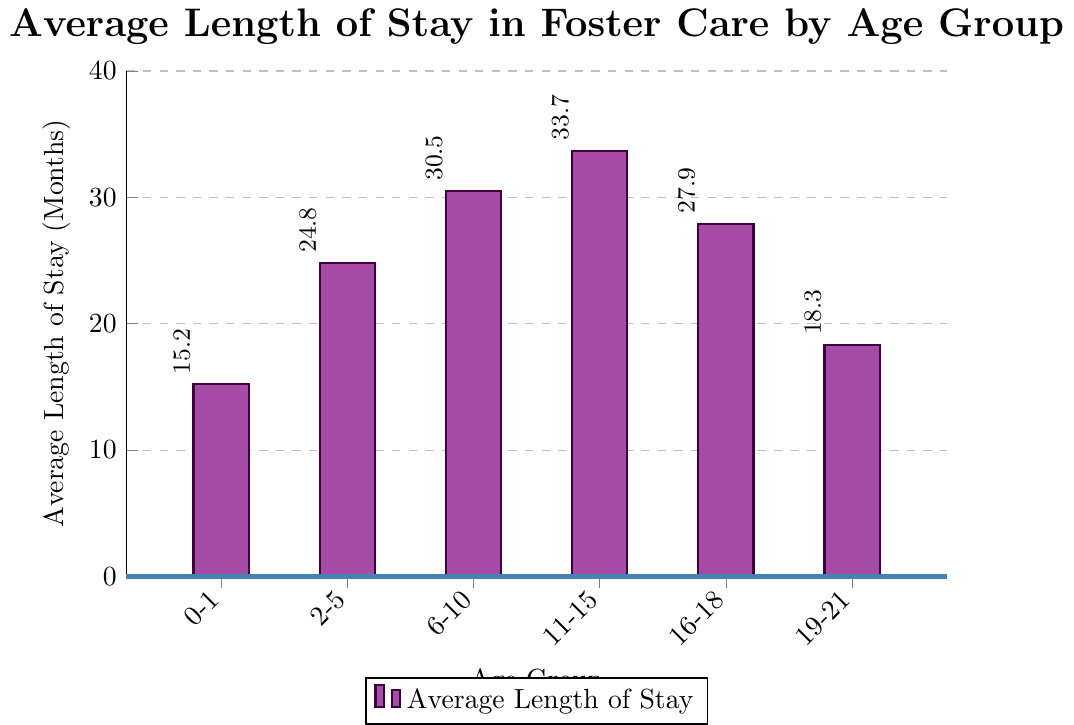Which age group has the longest average length of stay in foster care? The bar representing the age group 11-15 years reaches the highest point on the y-axis.
Answer: 11-15 years What is the difference in the average length of stay between the age group 11-15 years and 0-1 years? The average length of stay for 11-15 years is 33.7 months and for 0-1 years it is 15.2 months. The difference is 33.7 - 15.2 = 18.5 months.
Answer: 18.5 months How many age groups have an average length of stay longer than 25 months? The bars for the age groups 6-10 years, 11-15 years, and 16-18 years extend above the 25-month mark.
Answer: 3 age groups Which age group has a shorter average length of stay: 6-10 years or 16-18 years? The average length of stay for 6-10 years is 30.5 months, and for 16-18 years is 27.9 months. Since 27.9 is less than 30.5, 16-18 years has a shorter average length of stay.
Answer: 16-18 years What is the combined average length of stay for the age groups 2-5 years and 19-21 years? The average length of stay for 2-5 years is 24.8 months and for 19-21 years it is 18.3 months. The combined value is 24.8 + 18.3 = 43.1 months.
Answer: 43.1 months By how much does the average length of stay for the age group 6-10 years exceed the stay for 2-5 years? The average length of stay for 6-10 years is 30.5 months, and for 2-5 years it is 24.8 months. The difference is 30.5 - 24.8 = 5.7 months.
Answer: 5.7 months Identify any age groups with an average length of stay shorter than 20 months. The average length of stay for the age groups 0-1 years (15.2 months) and 19-21 years (18.3 months) are both less than 20 months.
Answer: 0-1 years, 19-21 years What is the average of the average lengths of stay across all age groups? Sum the average lengths of stay for all age groups: 15.2 + 24.8 + 30.5 + 33.7 + 27.9 + 18.3 = 150.4. There are 6 age groups. The average is 150.4 / 6 = 25.07 months.
Answer: 25.07 months 